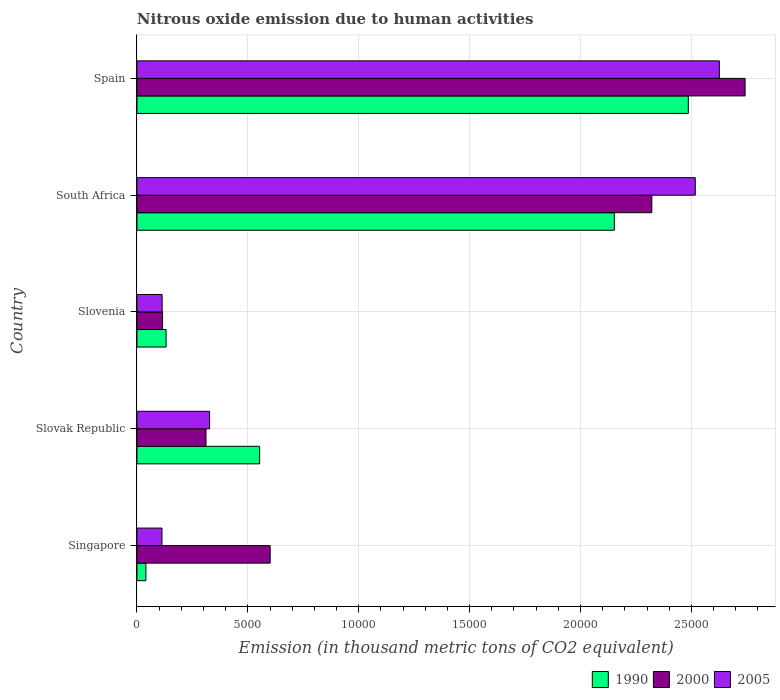Are the number of bars on each tick of the Y-axis equal?
Offer a terse response. Yes. How many bars are there on the 4th tick from the bottom?
Provide a short and direct response. 3. What is the label of the 4th group of bars from the top?
Offer a terse response. Slovak Republic. In how many cases, is the number of bars for a given country not equal to the number of legend labels?
Provide a succinct answer. 0. What is the amount of nitrous oxide emitted in 2000 in Spain?
Offer a terse response. 2.74e+04. Across all countries, what is the maximum amount of nitrous oxide emitted in 2000?
Your answer should be compact. 2.74e+04. Across all countries, what is the minimum amount of nitrous oxide emitted in 1990?
Your answer should be very brief. 403.4. In which country was the amount of nitrous oxide emitted in 2005 minimum?
Offer a terse response. Singapore. What is the total amount of nitrous oxide emitted in 1990 in the graph?
Your response must be concise. 5.36e+04. What is the difference between the amount of nitrous oxide emitted in 2000 in Slovak Republic and that in Slovenia?
Make the answer very short. 1958. What is the difference between the amount of nitrous oxide emitted in 1990 in Slovak Republic and the amount of nitrous oxide emitted in 2005 in Slovenia?
Your response must be concise. 4396.2. What is the average amount of nitrous oxide emitted in 1990 per country?
Give a very brief answer. 1.07e+04. What is the difference between the amount of nitrous oxide emitted in 2000 and amount of nitrous oxide emitted in 2005 in Spain?
Offer a terse response. 1159.6. In how many countries, is the amount of nitrous oxide emitted in 2005 greater than 17000 thousand metric tons?
Make the answer very short. 2. What is the ratio of the amount of nitrous oxide emitted in 2000 in Slovak Republic to that in Spain?
Provide a short and direct response. 0.11. What is the difference between the highest and the second highest amount of nitrous oxide emitted in 2000?
Your answer should be very brief. 4205.2. What is the difference between the highest and the lowest amount of nitrous oxide emitted in 2005?
Provide a succinct answer. 2.51e+04. In how many countries, is the amount of nitrous oxide emitted in 2005 greater than the average amount of nitrous oxide emitted in 2005 taken over all countries?
Keep it short and to the point. 2. Is the sum of the amount of nitrous oxide emitted in 2005 in Slovak Republic and Spain greater than the maximum amount of nitrous oxide emitted in 1990 across all countries?
Offer a very short reply. Yes. What does the 2nd bar from the top in Slovak Republic represents?
Your answer should be very brief. 2000. What does the 3rd bar from the bottom in Singapore represents?
Ensure brevity in your answer.  2005. How many bars are there?
Provide a succinct answer. 15. Are all the bars in the graph horizontal?
Your answer should be compact. Yes. What is the difference between two consecutive major ticks on the X-axis?
Give a very brief answer. 5000. How many legend labels are there?
Your answer should be compact. 3. What is the title of the graph?
Your answer should be very brief. Nitrous oxide emission due to human activities. What is the label or title of the X-axis?
Your answer should be compact. Emission (in thousand metric tons of CO2 equivalent). What is the label or title of the Y-axis?
Your answer should be very brief. Country. What is the Emission (in thousand metric tons of CO2 equivalent) in 1990 in Singapore?
Provide a succinct answer. 403.4. What is the Emission (in thousand metric tons of CO2 equivalent) in 2000 in Singapore?
Give a very brief answer. 6006.7. What is the Emission (in thousand metric tons of CO2 equivalent) of 2005 in Singapore?
Offer a very short reply. 1127.5. What is the Emission (in thousand metric tons of CO2 equivalent) of 1990 in Slovak Republic?
Offer a very short reply. 5531.9. What is the Emission (in thousand metric tons of CO2 equivalent) in 2000 in Slovak Republic?
Provide a short and direct response. 3112.3. What is the Emission (in thousand metric tons of CO2 equivalent) of 2005 in Slovak Republic?
Give a very brief answer. 3275.6. What is the Emission (in thousand metric tons of CO2 equivalent) in 1990 in Slovenia?
Ensure brevity in your answer.  1313.9. What is the Emission (in thousand metric tons of CO2 equivalent) of 2000 in Slovenia?
Ensure brevity in your answer.  1154.3. What is the Emission (in thousand metric tons of CO2 equivalent) of 2005 in Slovenia?
Give a very brief answer. 1135.7. What is the Emission (in thousand metric tons of CO2 equivalent) of 1990 in South Africa?
Give a very brief answer. 2.15e+04. What is the Emission (in thousand metric tons of CO2 equivalent) in 2000 in South Africa?
Your answer should be very brief. 2.32e+04. What is the Emission (in thousand metric tons of CO2 equivalent) in 2005 in South Africa?
Provide a short and direct response. 2.52e+04. What is the Emission (in thousand metric tons of CO2 equivalent) of 1990 in Spain?
Give a very brief answer. 2.49e+04. What is the Emission (in thousand metric tons of CO2 equivalent) of 2000 in Spain?
Offer a terse response. 2.74e+04. What is the Emission (in thousand metric tons of CO2 equivalent) in 2005 in Spain?
Give a very brief answer. 2.63e+04. Across all countries, what is the maximum Emission (in thousand metric tons of CO2 equivalent) in 1990?
Ensure brevity in your answer.  2.49e+04. Across all countries, what is the maximum Emission (in thousand metric tons of CO2 equivalent) in 2000?
Make the answer very short. 2.74e+04. Across all countries, what is the maximum Emission (in thousand metric tons of CO2 equivalent) in 2005?
Offer a very short reply. 2.63e+04. Across all countries, what is the minimum Emission (in thousand metric tons of CO2 equivalent) in 1990?
Ensure brevity in your answer.  403.4. Across all countries, what is the minimum Emission (in thousand metric tons of CO2 equivalent) of 2000?
Your answer should be compact. 1154.3. Across all countries, what is the minimum Emission (in thousand metric tons of CO2 equivalent) of 2005?
Make the answer very short. 1127.5. What is the total Emission (in thousand metric tons of CO2 equivalent) in 1990 in the graph?
Your answer should be compact. 5.36e+04. What is the total Emission (in thousand metric tons of CO2 equivalent) of 2000 in the graph?
Give a very brief answer. 6.09e+04. What is the total Emission (in thousand metric tons of CO2 equivalent) of 2005 in the graph?
Offer a terse response. 5.70e+04. What is the difference between the Emission (in thousand metric tons of CO2 equivalent) of 1990 in Singapore and that in Slovak Republic?
Provide a succinct answer. -5128.5. What is the difference between the Emission (in thousand metric tons of CO2 equivalent) in 2000 in Singapore and that in Slovak Republic?
Provide a succinct answer. 2894.4. What is the difference between the Emission (in thousand metric tons of CO2 equivalent) in 2005 in Singapore and that in Slovak Republic?
Provide a short and direct response. -2148.1. What is the difference between the Emission (in thousand metric tons of CO2 equivalent) of 1990 in Singapore and that in Slovenia?
Your answer should be very brief. -910.5. What is the difference between the Emission (in thousand metric tons of CO2 equivalent) in 2000 in Singapore and that in Slovenia?
Your answer should be compact. 4852.4. What is the difference between the Emission (in thousand metric tons of CO2 equivalent) in 1990 in Singapore and that in South Africa?
Your answer should be very brief. -2.11e+04. What is the difference between the Emission (in thousand metric tons of CO2 equivalent) in 2000 in Singapore and that in South Africa?
Your answer should be very brief. -1.72e+04. What is the difference between the Emission (in thousand metric tons of CO2 equivalent) of 2005 in Singapore and that in South Africa?
Ensure brevity in your answer.  -2.40e+04. What is the difference between the Emission (in thousand metric tons of CO2 equivalent) of 1990 in Singapore and that in Spain?
Your answer should be very brief. -2.45e+04. What is the difference between the Emission (in thousand metric tons of CO2 equivalent) of 2000 in Singapore and that in Spain?
Your response must be concise. -2.14e+04. What is the difference between the Emission (in thousand metric tons of CO2 equivalent) in 2005 in Singapore and that in Spain?
Offer a terse response. -2.51e+04. What is the difference between the Emission (in thousand metric tons of CO2 equivalent) in 1990 in Slovak Republic and that in Slovenia?
Offer a very short reply. 4218. What is the difference between the Emission (in thousand metric tons of CO2 equivalent) of 2000 in Slovak Republic and that in Slovenia?
Make the answer very short. 1958. What is the difference between the Emission (in thousand metric tons of CO2 equivalent) in 2005 in Slovak Republic and that in Slovenia?
Provide a short and direct response. 2139.9. What is the difference between the Emission (in thousand metric tons of CO2 equivalent) in 1990 in Slovak Republic and that in South Africa?
Make the answer very short. -1.60e+04. What is the difference between the Emission (in thousand metric tons of CO2 equivalent) of 2000 in Slovak Republic and that in South Africa?
Ensure brevity in your answer.  -2.01e+04. What is the difference between the Emission (in thousand metric tons of CO2 equivalent) of 2005 in Slovak Republic and that in South Africa?
Keep it short and to the point. -2.19e+04. What is the difference between the Emission (in thousand metric tons of CO2 equivalent) in 1990 in Slovak Republic and that in Spain?
Provide a short and direct response. -1.93e+04. What is the difference between the Emission (in thousand metric tons of CO2 equivalent) in 2000 in Slovak Republic and that in Spain?
Your answer should be compact. -2.43e+04. What is the difference between the Emission (in thousand metric tons of CO2 equivalent) in 2005 in Slovak Republic and that in Spain?
Your response must be concise. -2.30e+04. What is the difference between the Emission (in thousand metric tons of CO2 equivalent) in 1990 in Slovenia and that in South Africa?
Give a very brief answer. -2.02e+04. What is the difference between the Emission (in thousand metric tons of CO2 equivalent) of 2000 in Slovenia and that in South Africa?
Make the answer very short. -2.21e+04. What is the difference between the Emission (in thousand metric tons of CO2 equivalent) of 2005 in Slovenia and that in South Africa?
Provide a short and direct response. -2.40e+04. What is the difference between the Emission (in thousand metric tons of CO2 equivalent) in 1990 in Slovenia and that in Spain?
Provide a short and direct response. -2.35e+04. What is the difference between the Emission (in thousand metric tons of CO2 equivalent) in 2000 in Slovenia and that in Spain?
Provide a short and direct response. -2.63e+04. What is the difference between the Emission (in thousand metric tons of CO2 equivalent) of 2005 in Slovenia and that in Spain?
Your response must be concise. -2.51e+04. What is the difference between the Emission (in thousand metric tons of CO2 equivalent) in 1990 in South Africa and that in Spain?
Keep it short and to the point. -3335.2. What is the difference between the Emission (in thousand metric tons of CO2 equivalent) of 2000 in South Africa and that in Spain?
Ensure brevity in your answer.  -4205.2. What is the difference between the Emission (in thousand metric tons of CO2 equivalent) in 2005 in South Africa and that in Spain?
Ensure brevity in your answer.  -1086.5. What is the difference between the Emission (in thousand metric tons of CO2 equivalent) in 1990 in Singapore and the Emission (in thousand metric tons of CO2 equivalent) in 2000 in Slovak Republic?
Provide a short and direct response. -2708.9. What is the difference between the Emission (in thousand metric tons of CO2 equivalent) of 1990 in Singapore and the Emission (in thousand metric tons of CO2 equivalent) of 2005 in Slovak Republic?
Keep it short and to the point. -2872.2. What is the difference between the Emission (in thousand metric tons of CO2 equivalent) in 2000 in Singapore and the Emission (in thousand metric tons of CO2 equivalent) in 2005 in Slovak Republic?
Your answer should be very brief. 2731.1. What is the difference between the Emission (in thousand metric tons of CO2 equivalent) in 1990 in Singapore and the Emission (in thousand metric tons of CO2 equivalent) in 2000 in Slovenia?
Ensure brevity in your answer.  -750.9. What is the difference between the Emission (in thousand metric tons of CO2 equivalent) of 1990 in Singapore and the Emission (in thousand metric tons of CO2 equivalent) of 2005 in Slovenia?
Provide a succinct answer. -732.3. What is the difference between the Emission (in thousand metric tons of CO2 equivalent) of 2000 in Singapore and the Emission (in thousand metric tons of CO2 equivalent) of 2005 in Slovenia?
Make the answer very short. 4871. What is the difference between the Emission (in thousand metric tons of CO2 equivalent) of 1990 in Singapore and the Emission (in thousand metric tons of CO2 equivalent) of 2000 in South Africa?
Your answer should be compact. -2.28e+04. What is the difference between the Emission (in thousand metric tons of CO2 equivalent) of 1990 in Singapore and the Emission (in thousand metric tons of CO2 equivalent) of 2005 in South Africa?
Give a very brief answer. -2.48e+04. What is the difference between the Emission (in thousand metric tons of CO2 equivalent) of 2000 in Singapore and the Emission (in thousand metric tons of CO2 equivalent) of 2005 in South Africa?
Your answer should be very brief. -1.92e+04. What is the difference between the Emission (in thousand metric tons of CO2 equivalent) of 1990 in Singapore and the Emission (in thousand metric tons of CO2 equivalent) of 2000 in Spain?
Your answer should be compact. -2.70e+04. What is the difference between the Emission (in thousand metric tons of CO2 equivalent) in 1990 in Singapore and the Emission (in thousand metric tons of CO2 equivalent) in 2005 in Spain?
Ensure brevity in your answer.  -2.59e+04. What is the difference between the Emission (in thousand metric tons of CO2 equivalent) in 2000 in Singapore and the Emission (in thousand metric tons of CO2 equivalent) in 2005 in Spain?
Provide a succinct answer. -2.03e+04. What is the difference between the Emission (in thousand metric tons of CO2 equivalent) of 1990 in Slovak Republic and the Emission (in thousand metric tons of CO2 equivalent) of 2000 in Slovenia?
Ensure brevity in your answer.  4377.6. What is the difference between the Emission (in thousand metric tons of CO2 equivalent) in 1990 in Slovak Republic and the Emission (in thousand metric tons of CO2 equivalent) in 2005 in Slovenia?
Give a very brief answer. 4396.2. What is the difference between the Emission (in thousand metric tons of CO2 equivalent) in 2000 in Slovak Republic and the Emission (in thousand metric tons of CO2 equivalent) in 2005 in Slovenia?
Give a very brief answer. 1976.6. What is the difference between the Emission (in thousand metric tons of CO2 equivalent) of 1990 in Slovak Republic and the Emission (in thousand metric tons of CO2 equivalent) of 2000 in South Africa?
Ensure brevity in your answer.  -1.77e+04. What is the difference between the Emission (in thousand metric tons of CO2 equivalent) of 1990 in Slovak Republic and the Emission (in thousand metric tons of CO2 equivalent) of 2005 in South Africa?
Make the answer very short. -1.96e+04. What is the difference between the Emission (in thousand metric tons of CO2 equivalent) in 2000 in Slovak Republic and the Emission (in thousand metric tons of CO2 equivalent) in 2005 in South Africa?
Your response must be concise. -2.21e+04. What is the difference between the Emission (in thousand metric tons of CO2 equivalent) in 1990 in Slovak Republic and the Emission (in thousand metric tons of CO2 equivalent) in 2000 in Spain?
Offer a very short reply. -2.19e+04. What is the difference between the Emission (in thousand metric tons of CO2 equivalent) in 1990 in Slovak Republic and the Emission (in thousand metric tons of CO2 equivalent) in 2005 in Spain?
Keep it short and to the point. -2.07e+04. What is the difference between the Emission (in thousand metric tons of CO2 equivalent) in 2000 in Slovak Republic and the Emission (in thousand metric tons of CO2 equivalent) in 2005 in Spain?
Give a very brief answer. -2.32e+04. What is the difference between the Emission (in thousand metric tons of CO2 equivalent) of 1990 in Slovenia and the Emission (in thousand metric tons of CO2 equivalent) of 2000 in South Africa?
Your response must be concise. -2.19e+04. What is the difference between the Emission (in thousand metric tons of CO2 equivalent) in 1990 in Slovenia and the Emission (in thousand metric tons of CO2 equivalent) in 2005 in South Africa?
Your response must be concise. -2.39e+04. What is the difference between the Emission (in thousand metric tons of CO2 equivalent) of 2000 in Slovenia and the Emission (in thousand metric tons of CO2 equivalent) of 2005 in South Africa?
Your answer should be compact. -2.40e+04. What is the difference between the Emission (in thousand metric tons of CO2 equivalent) of 1990 in Slovenia and the Emission (in thousand metric tons of CO2 equivalent) of 2000 in Spain?
Make the answer very short. -2.61e+04. What is the difference between the Emission (in thousand metric tons of CO2 equivalent) in 1990 in Slovenia and the Emission (in thousand metric tons of CO2 equivalent) in 2005 in Spain?
Ensure brevity in your answer.  -2.49e+04. What is the difference between the Emission (in thousand metric tons of CO2 equivalent) in 2000 in Slovenia and the Emission (in thousand metric tons of CO2 equivalent) in 2005 in Spain?
Ensure brevity in your answer.  -2.51e+04. What is the difference between the Emission (in thousand metric tons of CO2 equivalent) of 1990 in South Africa and the Emission (in thousand metric tons of CO2 equivalent) of 2000 in Spain?
Offer a very short reply. -5895.5. What is the difference between the Emission (in thousand metric tons of CO2 equivalent) in 1990 in South Africa and the Emission (in thousand metric tons of CO2 equivalent) in 2005 in Spain?
Your answer should be very brief. -4735.9. What is the difference between the Emission (in thousand metric tons of CO2 equivalent) in 2000 in South Africa and the Emission (in thousand metric tons of CO2 equivalent) in 2005 in Spain?
Provide a succinct answer. -3045.6. What is the average Emission (in thousand metric tons of CO2 equivalent) in 1990 per country?
Keep it short and to the point. 1.07e+04. What is the average Emission (in thousand metric tons of CO2 equivalent) of 2000 per country?
Your response must be concise. 1.22e+04. What is the average Emission (in thousand metric tons of CO2 equivalent) in 2005 per country?
Ensure brevity in your answer.  1.14e+04. What is the difference between the Emission (in thousand metric tons of CO2 equivalent) in 1990 and Emission (in thousand metric tons of CO2 equivalent) in 2000 in Singapore?
Offer a very short reply. -5603.3. What is the difference between the Emission (in thousand metric tons of CO2 equivalent) in 1990 and Emission (in thousand metric tons of CO2 equivalent) in 2005 in Singapore?
Provide a succinct answer. -724.1. What is the difference between the Emission (in thousand metric tons of CO2 equivalent) of 2000 and Emission (in thousand metric tons of CO2 equivalent) of 2005 in Singapore?
Provide a succinct answer. 4879.2. What is the difference between the Emission (in thousand metric tons of CO2 equivalent) in 1990 and Emission (in thousand metric tons of CO2 equivalent) in 2000 in Slovak Republic?
Make the answer very short. 2419.6. What is the difference between the Emission (in thousand metric tons of CO2 equivalent) of 1990 and Emission (in thousand metric tons of CO2 equivalent) of 2005 in Slovak Republic?
Your answer should be compact. 2256.3. What is the difference between the Emission (in thousand metric tons of CO2 equivalent) of 2000 and Emission (in thousand metric tons of CO2 equivalent) of 2005 in Slovak Republic?
Provide a succinct answer. -163.3. What is the difference between the Emission (in thousand metric tons of CO2 equivalent) in 1990 and Emission (in thousand metric tons of CO2 equivalent) in 2000 in Slovenia?
Keep it short and to the point. 159.6. What is the difference between the Emission (in thousand metric tons of CO2 equivalent) of 1990 and Emission (in thousand metric tons of CO2 equivalent) of 2005 in Slovenia?
Ensure brevity in your answer.  178.2. What is the difference between the Emission (in thousand metric tons of CO2 equivalent) of 2000 and Emission (in thousand metric tons of CO2 equivalent) of 2005 in Slovenia?
Offer a terse response. 18.6. What is the difference between the Emission (in thousand metric tons of CO2 equivalent) of 1990 and Emission (in thousand metric tons of CO2 equivalent) of 2000 in South Africa?
Provide a short and direct response. -1690.3. What is the difference between the Emission (in thousand metric tons of CO2 equivalent) of 1990 and Emission (in thousand metric tons of CO2 equivalent) of 2005 in South Africa?
Provide a short and direct response. -3649.4. What is the difference between the Emission (in thousand metric tons of CO2 equivalent) of 2000 and Emission (in thousand metric tons of CO2 equivalent) of 2005 in South Africa?
Your answer should be very brief. -1959.1. What is the difference between the Emission (in thousand metric tons of CO2 equivalent) of 1990 and Emission (in thousand metric tons of CO2 equivalent) of 2000 in Spain?
Offer a very short reply. -2560.3. What is the difference between the Emission (in thousand metric tons of CO2 equivalent) of 1990 and Emission (in thousand metric tons of CO2 equivalent) of 2005 in Spain?
Provide a short and direct response. -1400.7. What is the difference between the Emission (in thousand metric tons of CO2 equivalent) of 2000 and Emission (in thousand metric tons of CO2 equivalent) of 2005 in Spain?
Provide a short and direct response. 1159.6. What is the ratio of the Emission (in thousand metric tons of CO2 equivalent) in 1990 in Singapore to that in Slovak Republic?
Your response must be concise. 0.07. What is the ratio of the Emission (in thousand metric tons of CO2 equivalent) of 2000 in Singapore to that in Slovak Republic?
Make the answer very short. 1.93. What is the ratio of the Emission (in thousand metric tons of CO2 equivalent) of 2005 in Singapore to that in Slovak Republic?
Make the answer very short. 0.34. What is the ratio of the Emission (in thousand metric tons of CO2 equivalent) in 1990 in Singapore to that in Slovenia?
Your answer should be compact. 0.31. What is the ratio of the Emission (in thousand metric tons of CO2 equivalent) in 2000 in Singapore to that in Slovenia?
Your answer should be very brief. 5.2. What is the ratio of the Emission (in thousand metric tons of CO2 equivalent) of 2005 in Singapore to that in Slovenia?
Offer a terse response. 0.99. What is the ratio of the Emission (in thousand metric tons of CO2 equivalent) in 1990 in Singapore to that in South Africa?
Your response must be concise. 0.02. What is the ratio of the Emission (in thousand metric tons of CO2 equivalent) in 2000 in Singapore to that in South Africa?
Your answer should be very brief. 0.26. What is the ratio of the Emission (in thousand metric tons of CO2 equivalent) of 2005 in Singapore to that in South Africa?
Offer a very short reply. 0.04. What is the ratio of the Emission (in thousand metric tons of CO2 equivalent) in 1990 in Singapore to that in Spain?
Offer a terse response. 0.02. What is the ratio of the Emission (in thousand metric tons of CO2 equivalent) of 2000 in Singapore to that in Spain?
Keep it short and to the point. 0.22. What is the ratio of the Emission (in thousand metric tons of CO2 equivalent) in 2005 in Singapore to that in Spain?
Offer a terse response. 0.04. What is the ratio of the Emission (in thousand metric tons of CO2 equivalent) in 1990 in Slovak Republic to that in Slovenia?
Provide a succinct answer. 4.21. What is the ratio of the Emission (in thousand metric tons of CO2 equivalent) of 2000 in Slovak Republic to that in Slovenia?
Make the answer very short. 2.7. What is the ratio of the Emission (in thousand metric tons of CO2 equivalent) in 2005 in Slovak Republic to that in Slovenia?
Keep it short and to the point. 2.88. What is the ratio of the Emission (in thousand metric tons of CO2 equivalent) of 1990 in Slovak Republic to that in South Africa?
Make the answer very short. 0.26. What is the ratio of the Emission (in thousand metric tons of CO2 equivalent) in 2000 in Slovak Republic to that in South Africa?
Keep it short and to the point. 0.13. What is the ratio of the Emission (in thousand metric tons of CO2 equivalent) of 2005 in Slovak Republic to that in South Africa?
Ensure brevity in your answer.  0.13. What is the ratio of the Emission (in thousand metric tons of CO2 equivalent) of 1990 in Slovak Republic to that in Spain?
Offer a terse response. 0.22. What is the ratio of the Emission (in thousand metric tons of CO2 equivalent) of 2000 in Slovak Republic to that in Spain?
Your response must be concise. 0.11. What is the ratio of the Emission (in thousand metric tons of CO2 equivalent) of 2005 in Slovak Republic to that in Spain?
Your answer should be compact. 0.12. What is the ratio of the Emission (in thousand metric tons of CO2 equivalent) in 1990 in Slovenia to that in South Africa?
Provide a short and direct response. 0.06. What is the ratio of the Emission (in thousand metric tons of CO2 equivalent) of 2000 in Slovenia to that in South Africa?
Ensure brevity in your answer.  0.05. What is the ratio of the Emission (in thousand metric tons of CO2 equivalent) of 2005 in Slovenia to that in South Africa?
Ensure brevity in your answer.  0.05. What is the ratio of the Emission (in thousand metric tons of CO2 equivalent) of 1990 in Slovenia to that in Spain?
Your answer should be very brief. 0.05. What is the ratio of the Emission (in thousand metric tons of CO2 equivalent) in 2000 in Slovenia to that in Spain?
Your response must be concise. 0.04. What is the ratio of the Emission (in thousand metric tons of CO2 equivalent) of 2005 in Slovenia to that in Spain?
Give a very brief answer. 0.04. What is the ratio of the Emission (in thousand metric tons of CO2 equivalent) in 1990 in South Africa to that in Spain?
Provide a short and direct response. 0.87. What is the ratio of the Emission (in thousand metric tons of CO2 equivalent) in 2000 in South Africa to that in Spain?
Offer a terse response. 0.85. What is the ratio of the Emission (in thousand metric tons of CO2 equivalent) in 2005 in South Africa to that in Spain?
Your answer should be compact. 0.96. What is the difference between the highest and the second highest Emission (in thousand metric tons of CO2 equivalent) of 1990?
Ensure brevity in your answer.  3335.2. What is the difference between the highest and the second highest Emission (in thousand metric tons of CO2 equivalent) of 2000?
Make the answer very short. 4205.2. What is the difference between the highest and the second highest Emission (in thousand metric tons of CO2 equivalent) of 2005?
Provide a succinct answer. 1086.5. What is the difference between the highest and the lowest Emission (in thousand metric tons of CO2 equivalent) in 1990?
Offer a very short reply. 2.45e+04. What is the difference between the highest and the lowest Emission (in thousand metric tons of CO2 equivalent) of 2000?
Provide a short and direct response. 2.63e+04. What is the difference between the highest and the lowest Emission (in thousand metric tons of CO2 equivalent) of 2005?
Your response must be concise. 2.51e+04. 